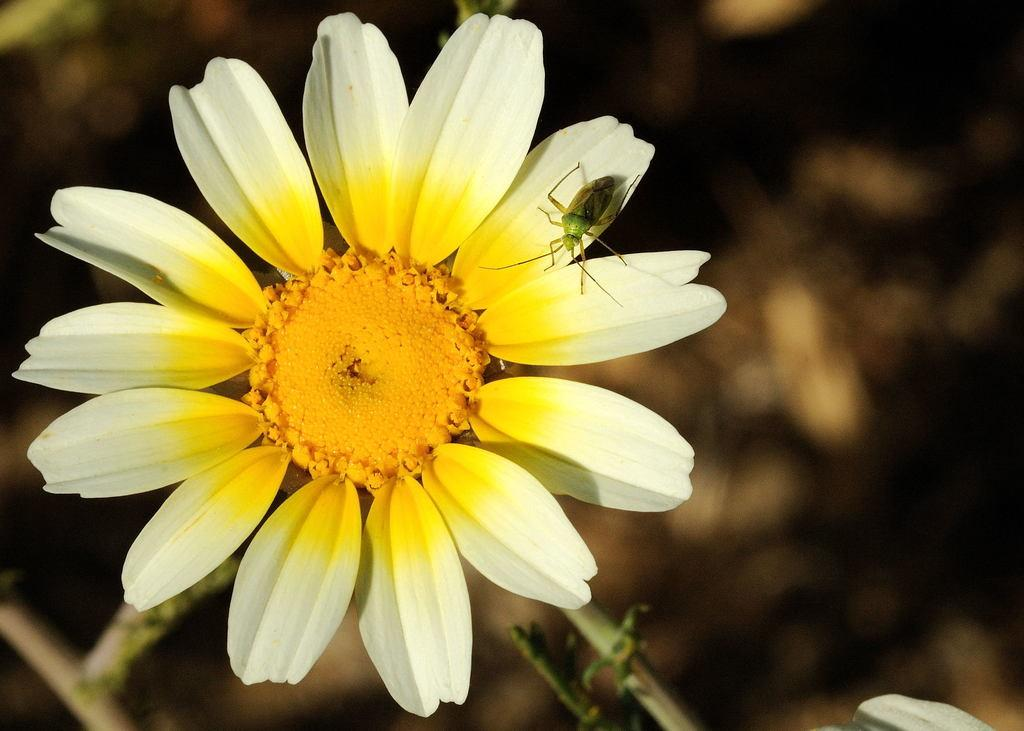What is the main subject of the image? There is a flower in the image. Is there anything else present on the flower? Yes, there is an insect on the flower. What part of the flower is connected to the stem? There are stems associated with the flower. How many family members can be seen in the image? There is no reference to a family or any family members in the image, as it features a flower with an insect on it. 